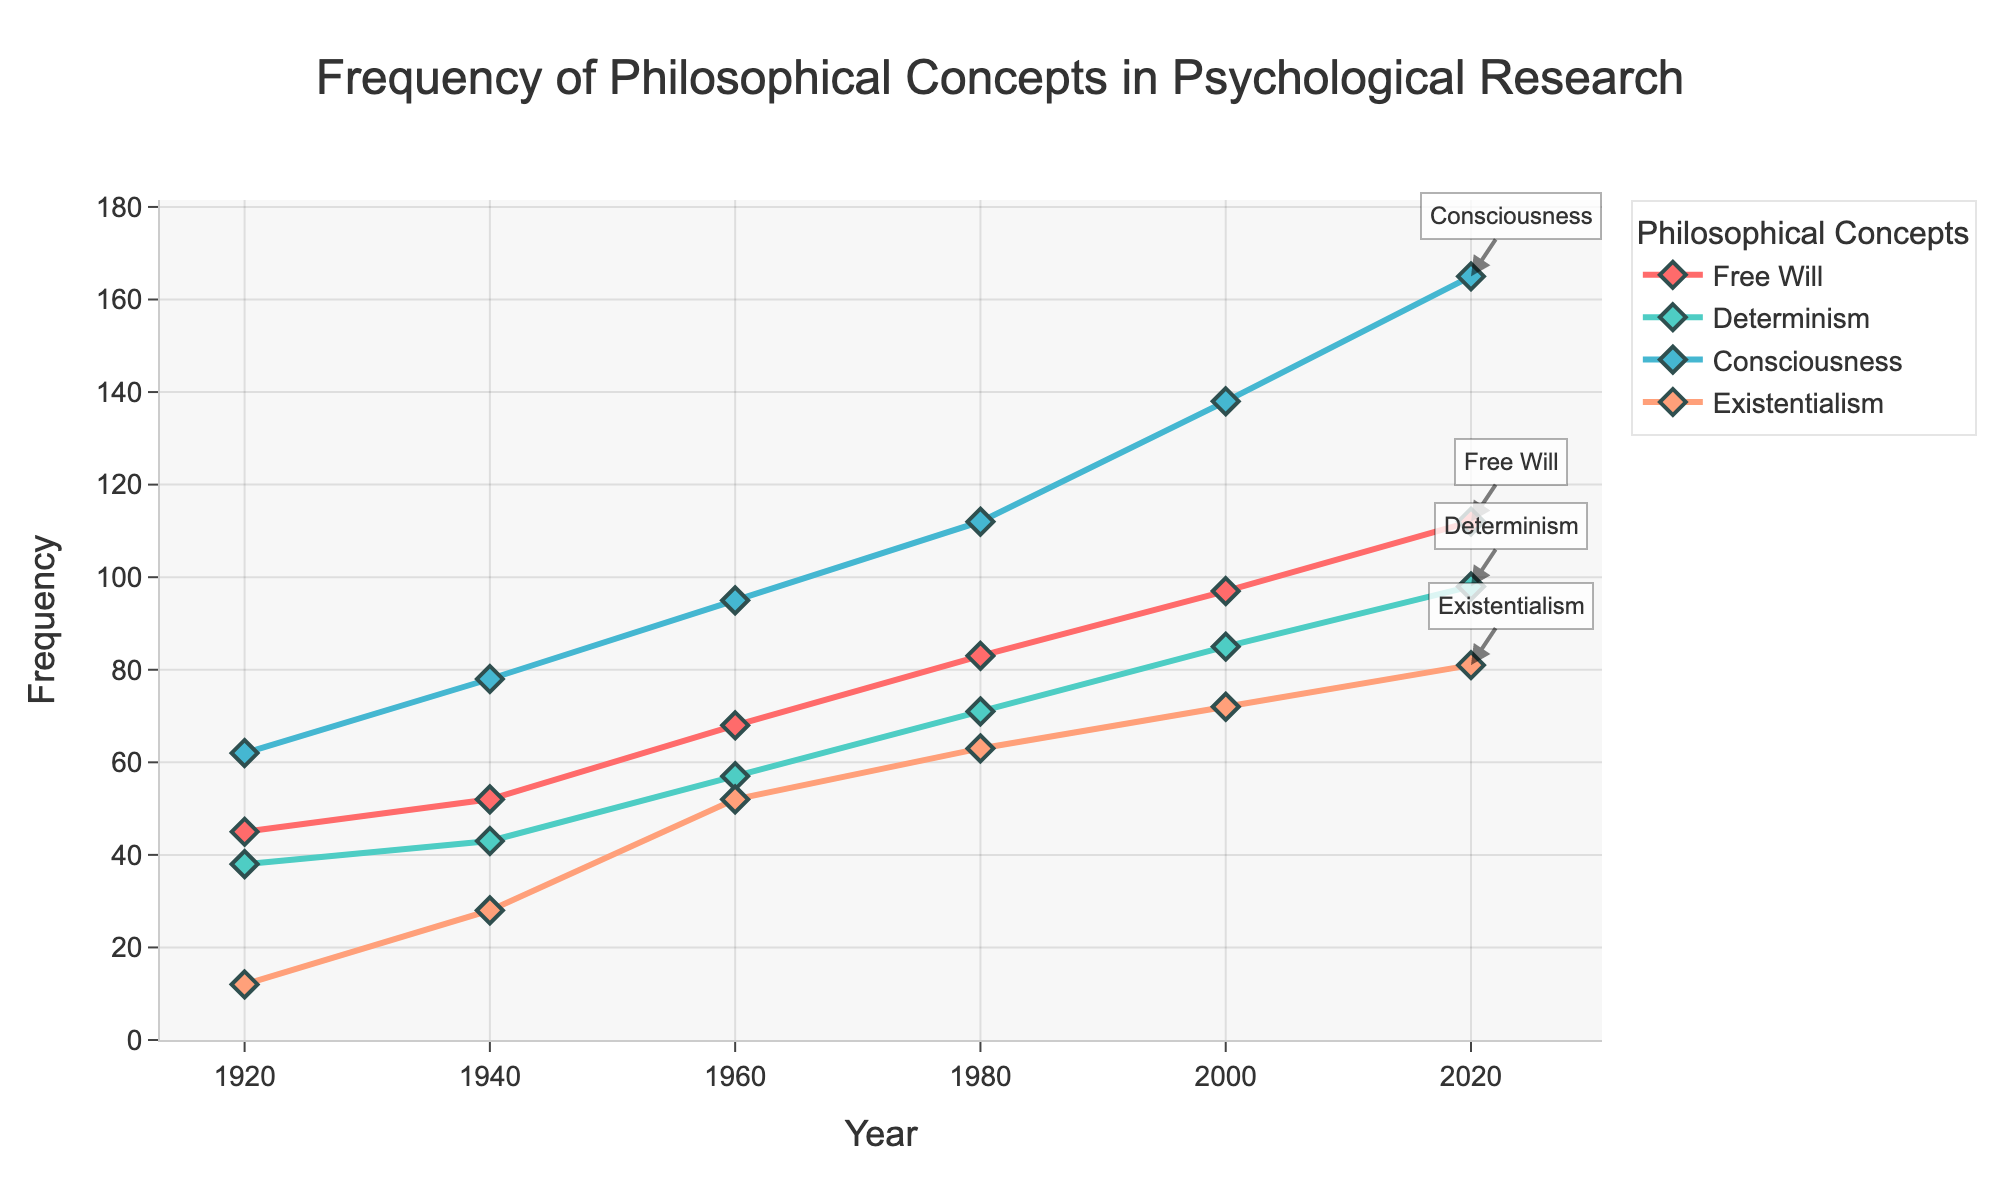What is the title of the figure? The title of the figure is displayed at the top and provides a summary of what the plot represents. This information is often crucial for understanding the context of the data.
Answer: Frequency of Philosophical Concepts in Psychological Research What are the four philosophical concepts shown in the figure? The figure has a legend that lists the names of the different philosophical concepts being tracked. These are essential for interpreting which lines correspond to which concepts.
Answer: Free Will, Determinism, Consciousness, Existentialism How many data points are there for each philosophical concept? Each concept has five data points, one for each of the years 1920, 1940, 1960, 1980, and 2020, which can be seen along the x-axis where lines and markers are plotted.
Answer: 5 Which philosophical concept has the highest frequency in the year 2020? In the plot, by looking at the marker furthest up on the y-axis for the year 2020, we identify the corresponding concept.
Answer: Consciousness How did the frequency of Free Will change from 1920 to 2020? To find the change, we locate the frequencies for Free Will in the years 1920 and 2020 in the plot and calculate the difference.
Answer: Increased by 67 (from 45 to 112) Which concepts showed an increase in frequency over the century? By examining the trend lines for each concept and noting those that slope upwards from 1920 to 2020, we determine which concepts increased in frequency.
Answer: All four concepts (Free Will, Determinism, Consciousness, Existentialism) What is the combined frequency of the four philosophical concepts in 1940? Summing the frequencies of all four concepts in 1940 by looking at the markers in the plot provides us with the combined frequency.
Answer: 201 Compare the increase in frequency of Determinism and Existentialism from 1940 to 1980. By checking the y-values for Determinism and Existentialism in 1940 and 1980 in the plot and calculating the difference for each concept, we can compare their increases.
Answer: Determinism increased by 28, Existentialism by 35 (43 to 71 vs. 28 to 63) What can you infer about the trend of Consciousness in psychological research? Observing the plot over the years, we look at the general slope of the line representing Consciousness to infer whether it is trending upward, downward, or staying constant.
Answer: It is steadily increasing At what rate did the frequency of Existentialism increase per decade on average from 1920 to 2020? To find the average rate, we take the total increase in Existentialism's frequency over 100 years and divide it by the number of decades (10).
Answer: 0.69 per year (and hence about 6.9 per decade) 